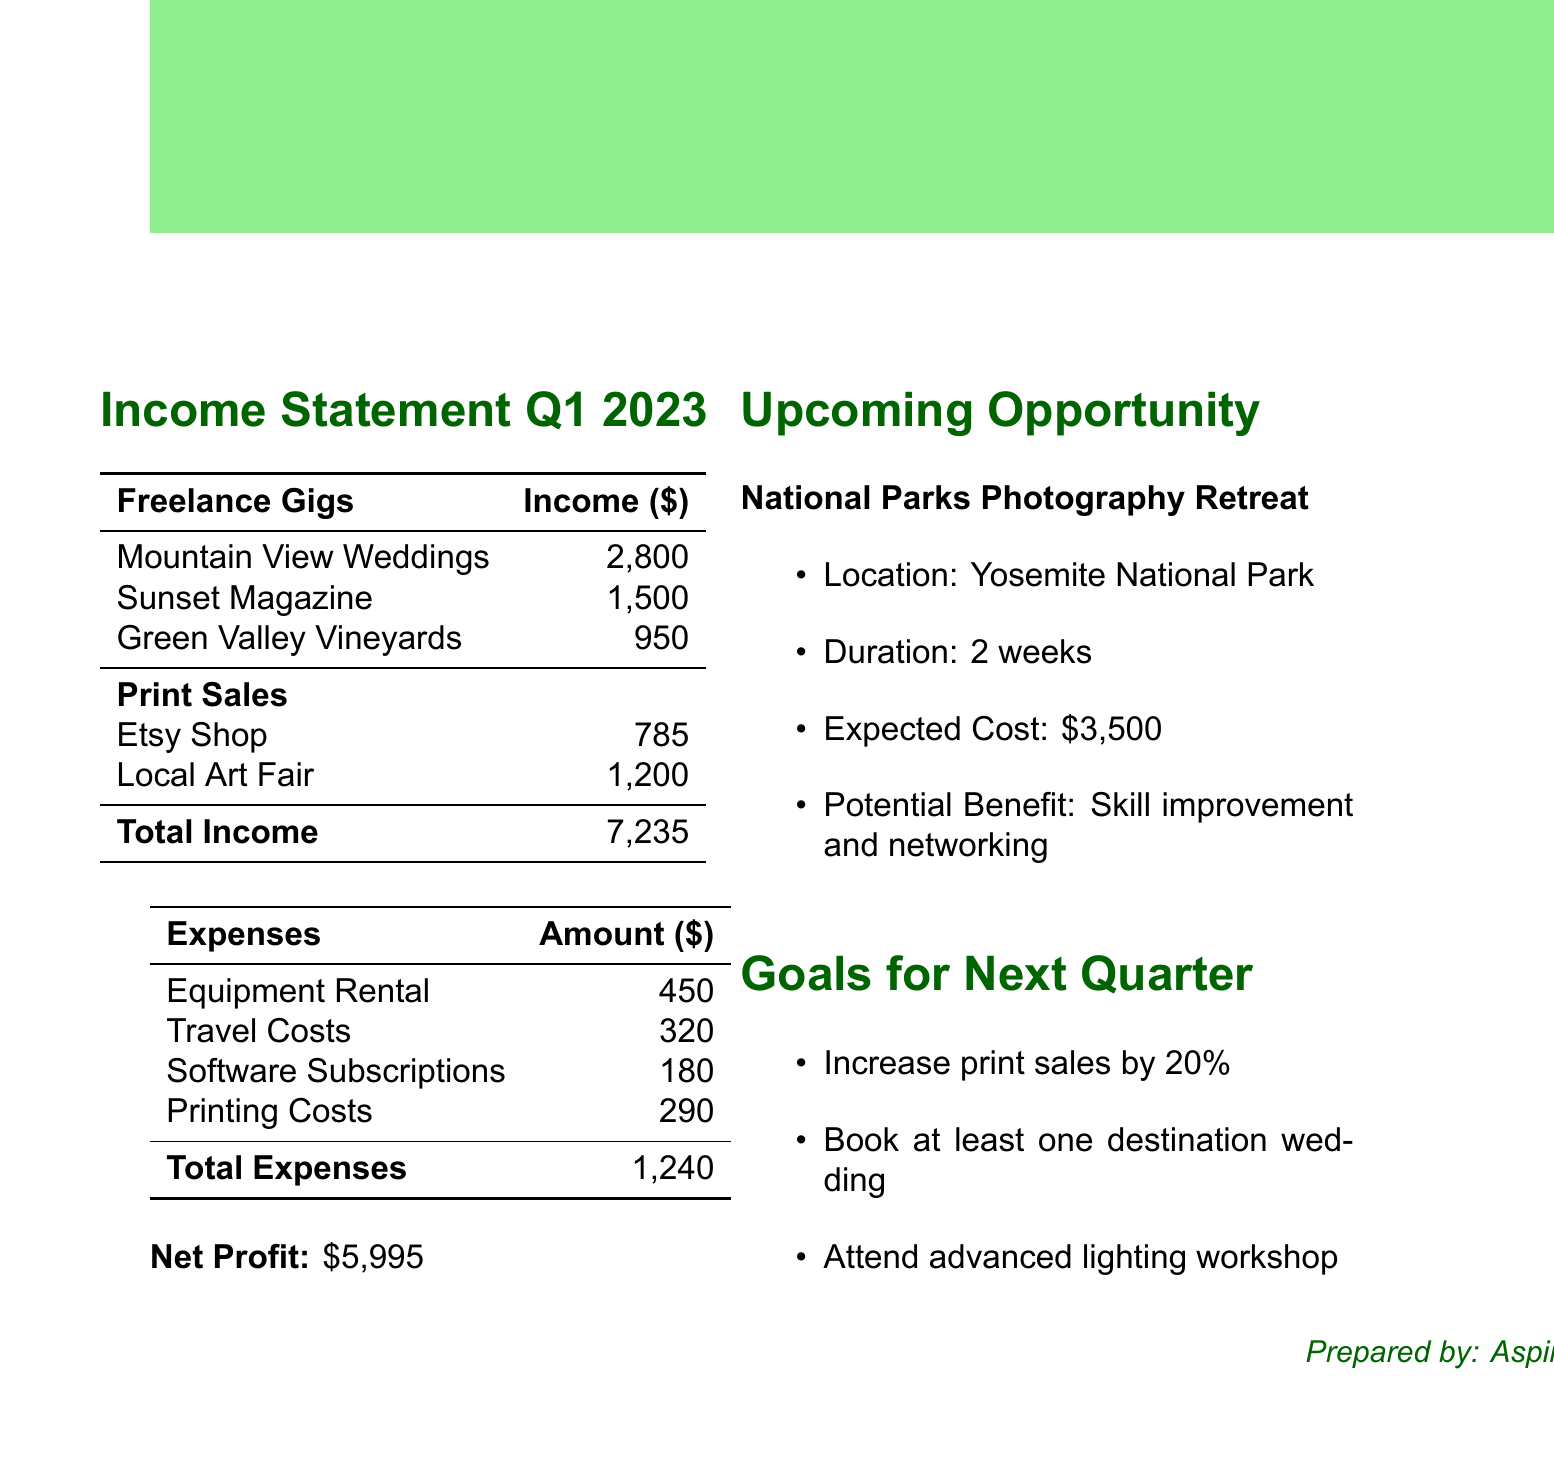What was the total income in Q1 2023? The total income is outlined in the financial summary section of the document, which states a total income of $7235.
Answer: $7235 How much did you earn from Mountain View Weddings? The income earned from Mountain View Weddings is specified in the freelance gigs section of the document. It states $2800 for the Spring Wedding Package.
Answer: $2800 What were the total expenses for Q1 2023? The total expenses are provided in the expenses section, summarizing to $1240.
Answer: $1240 What is the net profit for this quarter? The net profit is calculated as total income minus total expenses, which is detailed in the financial summary as $5995.
Answer: $5995 What is the expected cost for the National Parks Photography Retreat? The expected cost for the National Parks Photography Retreat is noted in the upcoming opportunities section, which is $3500.
Answer: $3500 What goal involves print sales? The goal to increase print sales by 20% is mentioned in the goals for the next quarter section of the document.
Answer: Increase print sales by 20% How many freelance gigs are listed for Q1 2023? The freelance gigs section lists three individual gigs: Mountain View Weddings, Sunset Magazine, and Green Valley Vineyards.
Answer: Three What is the location of the upcoming photography retreat? The location for the National Parks Photography Retreat is specified as Yosemite National Park.
Answer: Yosemite National Park What type of workshop is planned for the next quarter? The planned workshop is an advanced lighting workshop, mentioned under the goals for the next quarter.
Answer: Advanced lighting workshop 